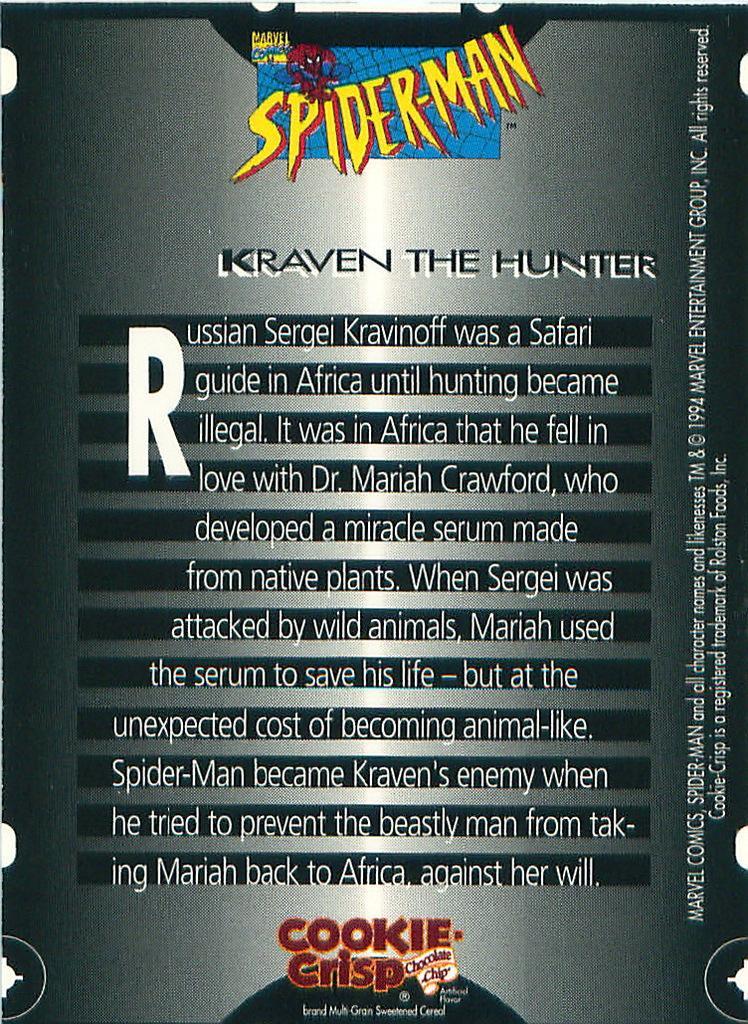Could you give a brief overview of what you see in this image? In this image we can see a poster which is in black color on which we can see some edited text and logos. 